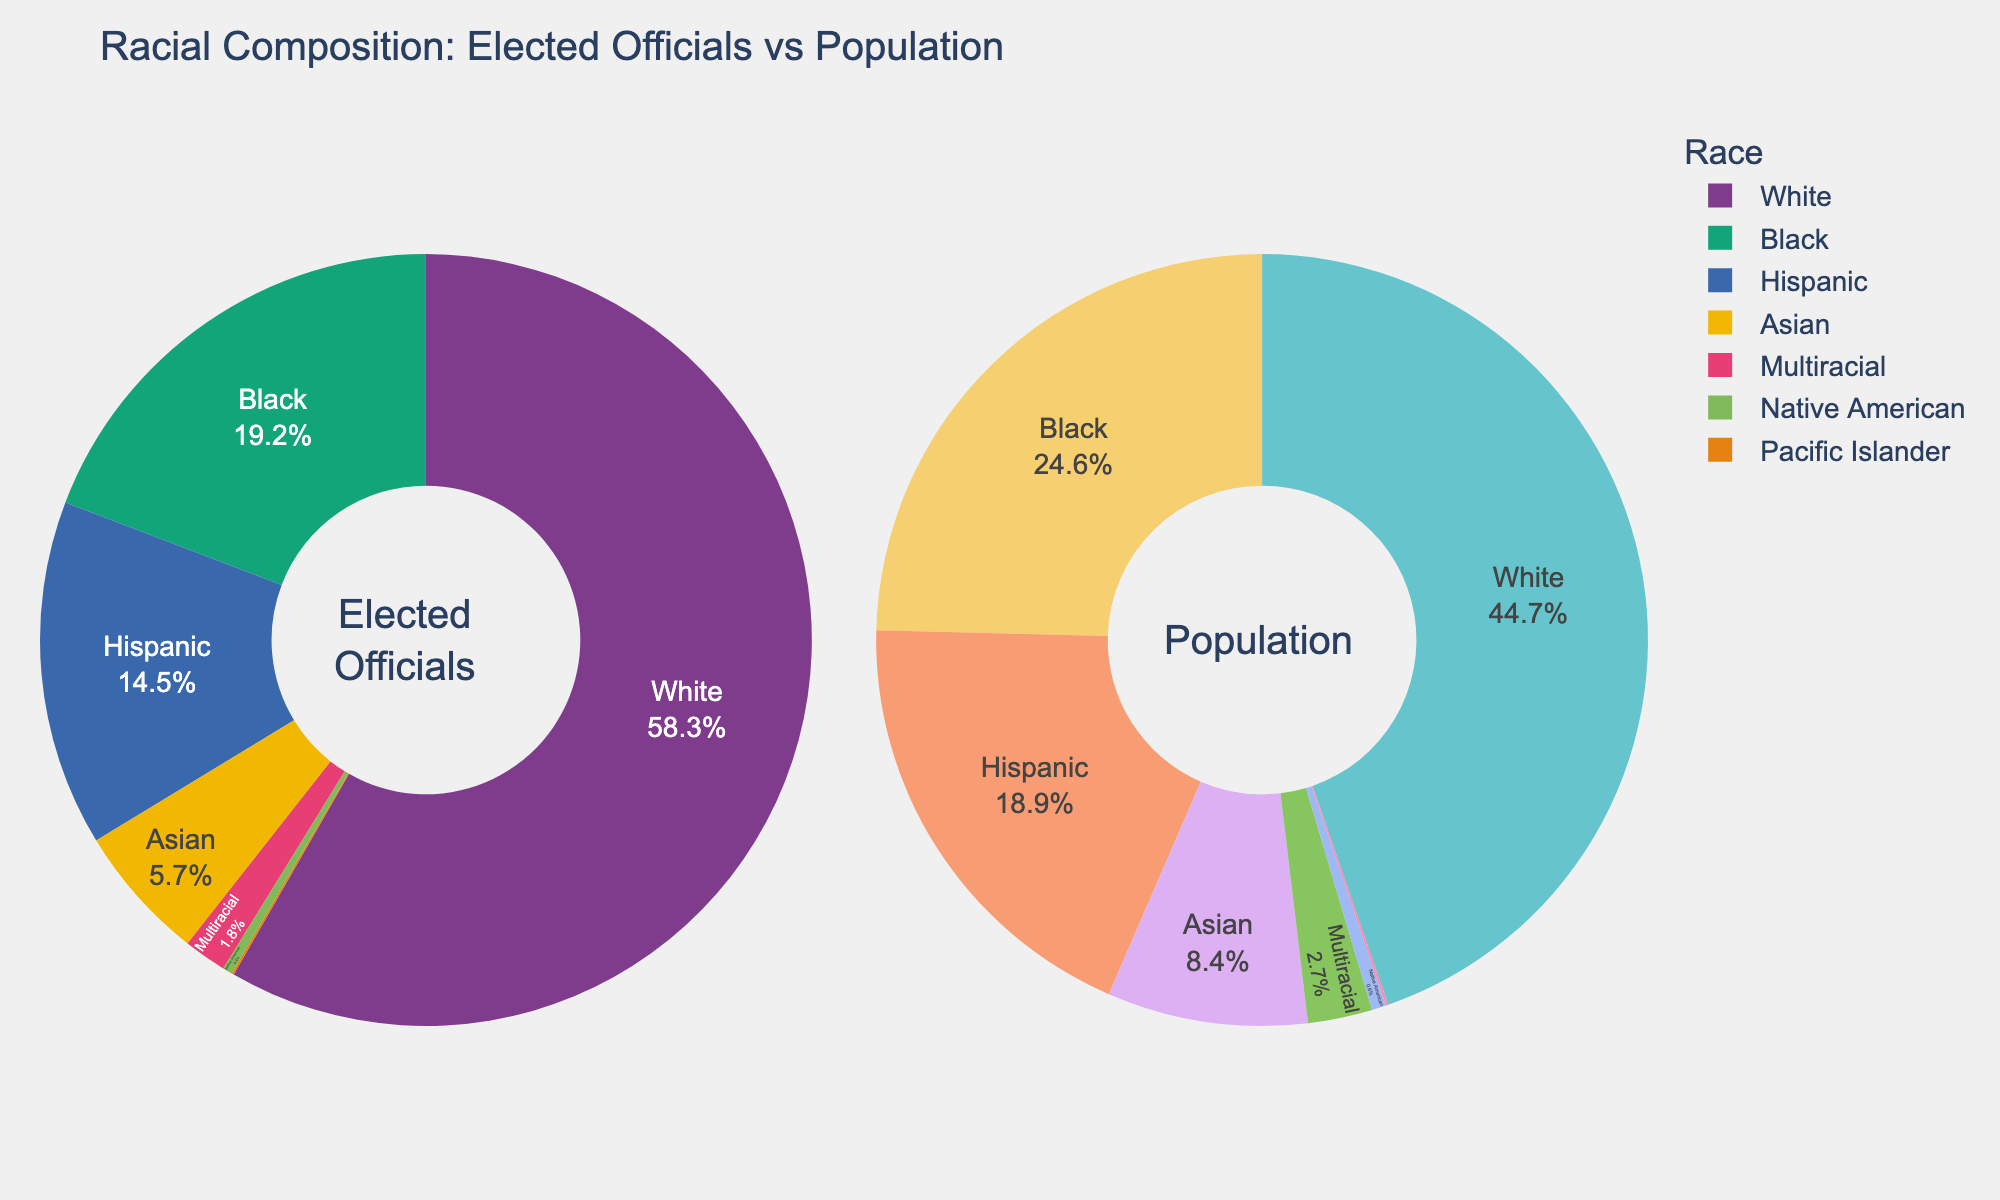What is the combined percentage of Black and Hispanic elected officials? To find the combined percentage of Black and Hispanic elected officials, add their respective percentages: 19.2% (Black) + 14.5% (Hispanic) = 33.7%
Answer: 33.7% Which racial group has a higher representation in the population compared to elected officials—Asian or Hispanic? Compare the percentages of Asians and Hispanics in the population to their percentages among elected officials. Asians are 8.4% of the population vs. 5.7% in elected officials. Hispanics are 18.9% of the population vs. 14.5% in elected officials. Both groups have higher representation in the population, but Hispanics have a larger margin.
Answer: Hispanic Are Native Americans exactly proportionate in elected officials and population? Compare the percentages of Native Americans in the population (0.6%) to their percentage among elected officials (0.4%). They are not exactly proportionate.
Answer: No Which group shows the largest discrepancy between elected officials and population representation? Calculate the absolute differences between the percentages for each group: White (58.3% - 44.7% = 13.6%), Black (19.2% - 24.6% = -5.4%), Hispanic (14.5% - 18.9% = -4.4%), Asian (5.7% - 8.4% = -2.7%), Multiracial (1.8% - 2.7% = -0.9%), Native American (0.4% - 0.6% = -0.2%), Pacific Islander (0.1% - 0.1% = 0%). The largest discrepancy is for Whites: 13.6%.
Answer: White Which racial group has the most similar percentage in both elected officials and population? Calculate the differences between the percentages for each group: White (58.3% - 44.7% = 13.6%), Black (19.2% - 24.6% = 5.4%), Hispanic (14.5% - 18.9% = 4.4%), Asian (5.7% - 8.4% = 2.7%), Multiracial (1.8% - 2.7% = 0.9%), Native American (0.4% - 0.6% = 0.2%), Pacific Islander (0.1% - 0.1% = 0%). The smallest difference is for Pacific Islanders: 0%.
Answer: Pacific Islander 